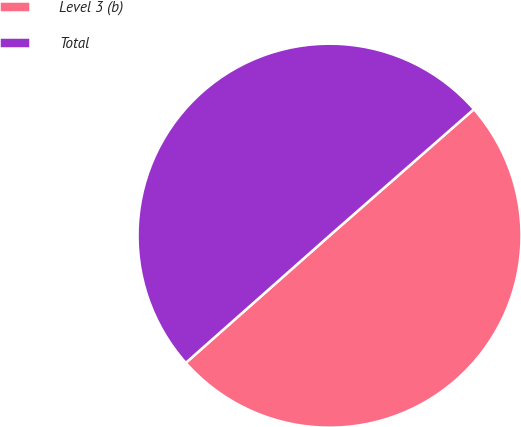Convert chart. <chart><loc_0><loc_0><loc_500><loc_500><pie_chart><fcel>Level 3 (b)<fcel>Total<nl><fcel>49.92%<fcel>50.08%<nl></chart> 